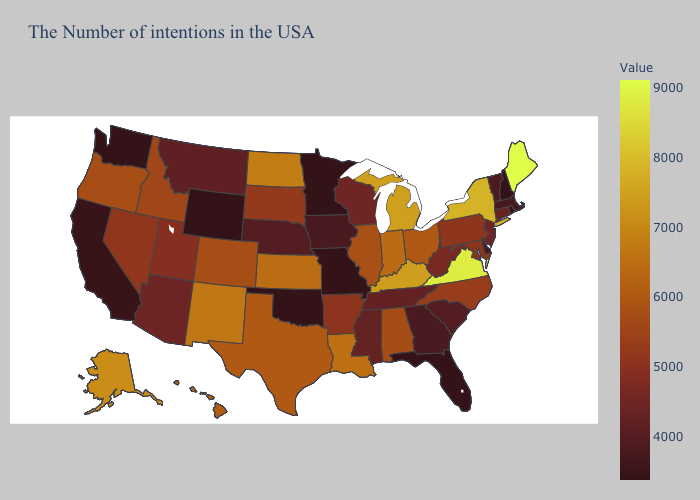Among the states that border Idaho , which have the highest value?
Write a very short answer. Oregon. Does Massachusetts have the highest value in the Northeast?
Be succinct. No. Does the map have missing data?
Be succinct. No. Which states have the lowest value in the South?
Be succinct. Florida, Oklahoma. Does the map have missing data?
Be succinct. No. Among the states that border Louisiana , which have the highest value?
Answer briefly. Texas. 